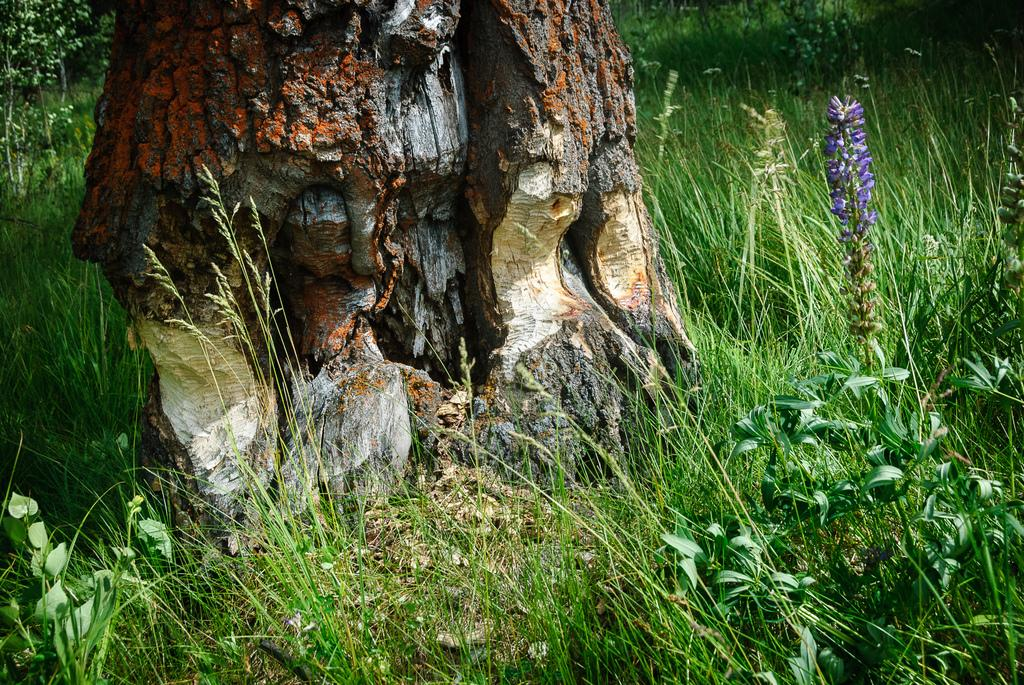What is the main subject in the middle of the image? There is a trunk of a tree in the middle of the image. What can be seen at the bottom of the image? There are small plants at the bottom of the image. What type of vegetation is visible in the image? There is grass visible in the image. Where is the flower plant located in the image? There is a flower plant on the right side of the image. What type of linen is draped over the tree trunk in the image? There is no linen draped over the tree trunk in the image; it is just the trunk of the tree. 